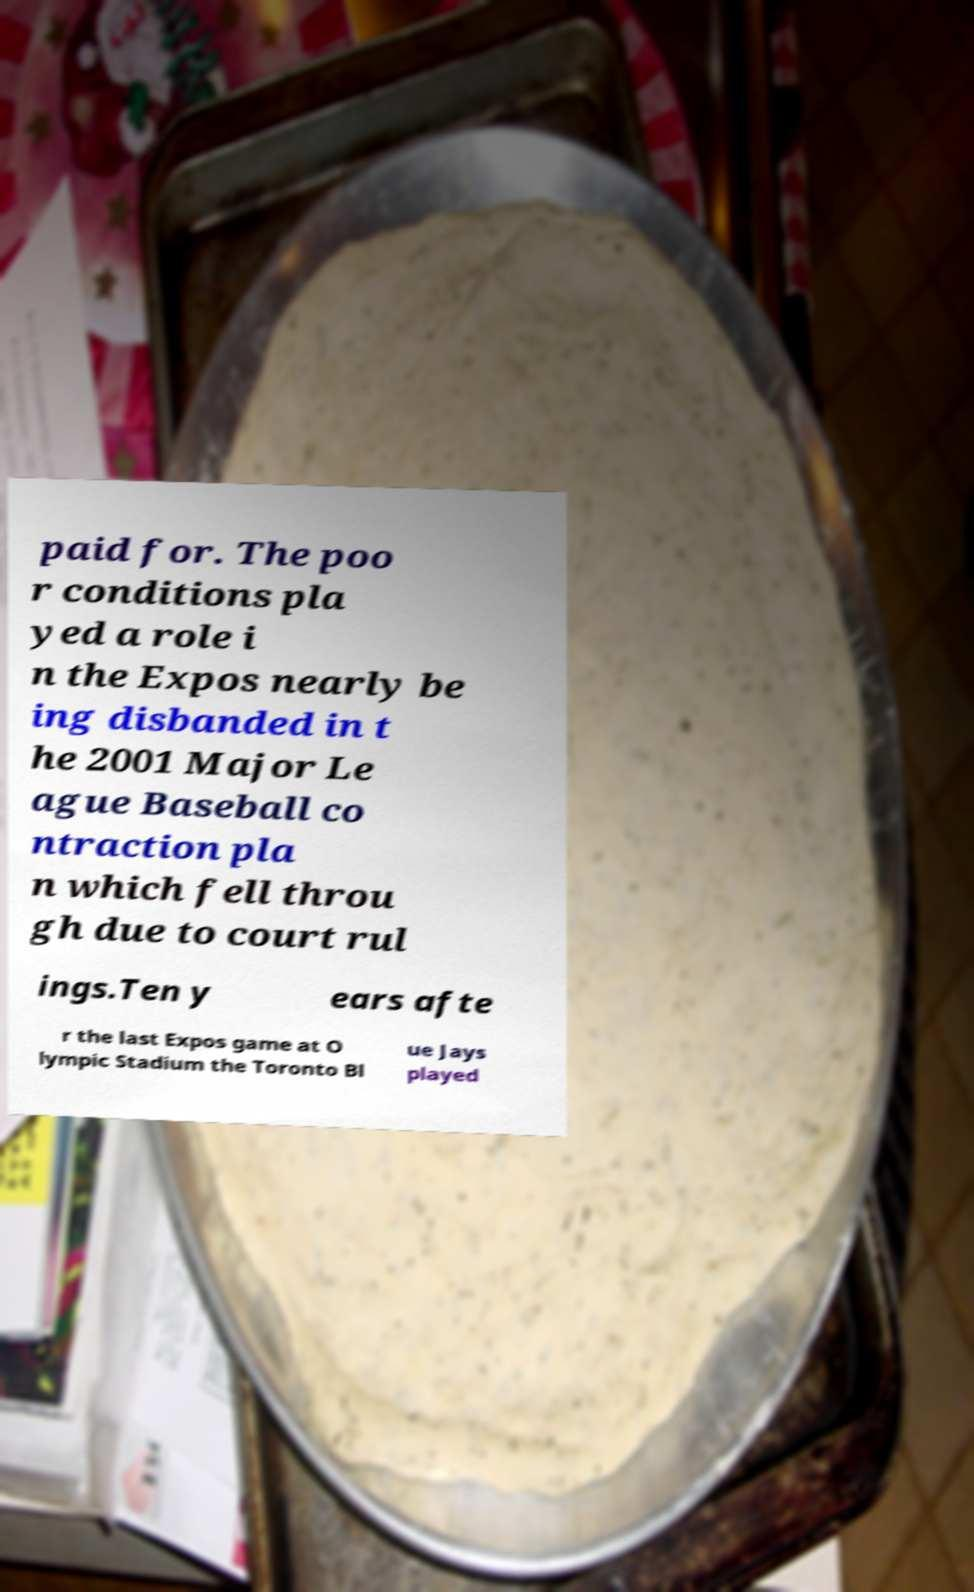Please read and relay the text visible in this image. What does it say? paid for. The poo r conditions pla yed a role i n the Expos nearly be ing disbanded in t he 2001 Major Le ague Baseball co ntraction pla n which fell throu gh due to court rul ings.Ten y ears afte r the last Expos game at O lympic Stadium the Toronto Bl ue Jays played 